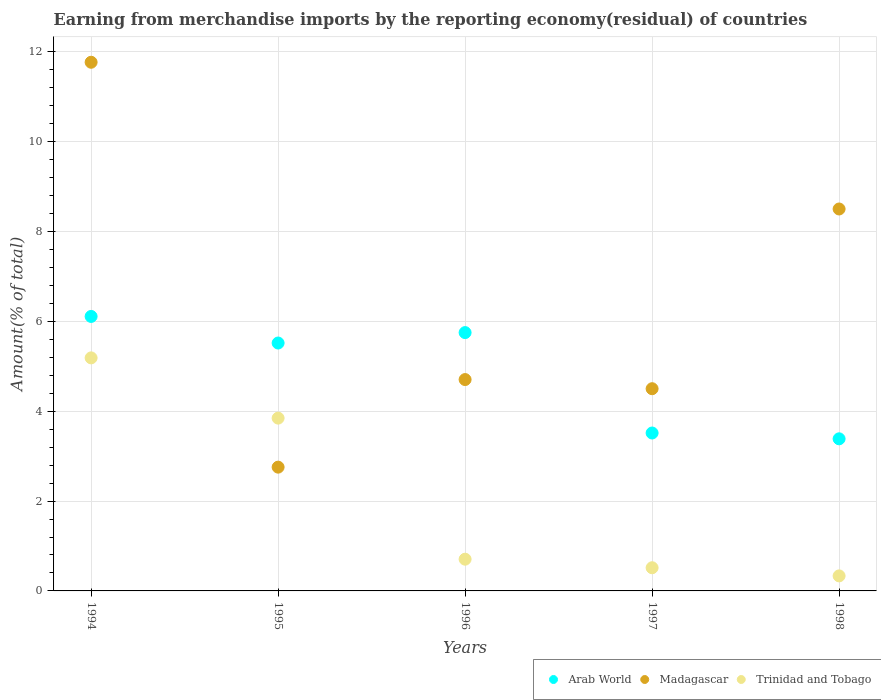How many different coloured dotlines are there?
Ensure brevity in your answer.  3. Is the number of dotlines equal to the number of legend labels?
Keep it short and to the point. Yes. What is the percentage of amount earned from merchandise imports in Trinidad and Tobago in 1996?
Your answer should be compact. 0.71. Across all years, what is the maximum percentage of amount earned from merchandise imports in Arab World?
Provide a succinct answer. 6.11. Across all years, what is the minimum percentage of amount earned from merchandise imports in Trinidad and Tobago?
Provide a succinct answer. 0.33. In which year was the percentage of amount earned from merchandise imports in Madagascar maximum?
Make the answer very short. 1994. In which year was the percentage of amount earned from merchandise imports in Arab World minimum?
Make the answer very short. 1998. What is the total percentage of amount earned from merchandise imports in Arab World in the graph?
Provide a succinct answer. 24.28. What is the difference between the percentage of amount earned from merchandise imports in Madagascar in 1995 and that in 1998?
Offer a terse response. -5.75. What is the difference between the percentage of amount earned from merchandise imports in Madagascar in 1998 and the percentage of amount earned from merchandise imports in Trinidad and Tobago in 1995?
Make the answer very short. 4.66. What is the average percentage of amount earned from merchandise imports in Arab World per year?
Provide a succinct answer. 4.86. In the year 1994, what is the difference between the percentage of amount earned from merchandise imports in Madagascar and percentage of amount earned from merchandise imports in Arab World?
Make the answer very short. 5.66. What is the ratio of the percentage of amount earned from merchandise imports in Arab World in 1996 to that in 1998?
Your answer should be compact. 1.7. Is the difference between the percentage of amount earned from merchandise imports in Madagascar in 1994 and 1998 greater than the difference between the percentage of amount earned from merchandise imports in Arab World in 1994 and 1998?
Provide a short and direct response. Yes. What is the difference between the highest and the second highest percentage of amount earned from merchandise imports in Arab World?
Give a very brief answer. 0.36. What is the difference between the highest and the lowest percentage of amount earned from merchandise imports in Trinidad and Tobago?
Ensure brevity in your answer.  4.85. In how many years, is the percentage of amount earned from merchandise imports in Trinidad and Tobago greater than the average percentage of amount earned from merchandise imports in Trinidad and Tobago taken over all years?
Offer a very short reply. 2. Is it the case that in every year, the sum of the percentage of amount earned from merchandise imports in Trinidad and Tobago and percentage of amount earned from merchandise imports in Arab World  is greater than the percentage of amount earned from merchandise imports in Madagascar?
Offer a terse response. No. Does the percentage of amount earned from merchandise imports in Arab World monotonically increase over the years?
Offer a very short reply. No. Is the percentage of amount earned from merchandise imports in Madagascar strictly less than the percentage of amount earned from merchandise imports in Trinidad and Tobago over the years?
Make the answer very short. No. How many years are there in the graph?
Your answer should be very brief. 5. What is the difference between two consecutive major ticks on the Y-axis?
Keep it short and to the point. 2. How many legend labels are there?
Offer a terse response. 3. How are the legend labels stacked?
Your answer should be compact. Horizontal. What is the title of the graph?
Offer a very short reply. Earning from merchandise imports by the reporting economy(residual) of countries. Does "Latin America(all income levels)" appear as one of the legend labels in the graph?
Offer a terse response. No. What is the label or title of the X-axis?
Your response must be concise. Years. What is the label or title of the Y-axis?
Provide a short and direct response. Amount(% of total). What is the Amount(% of total) of Arab World in 1994?
Make the answer very short. 6.11. What is the Amount(% of total) of Madagascar in 1994?
Offer a terse response. 11.77. What is the Amount(% of total) in Trinidad and Tobago in 1994?
Your answer should be very brief. 5.19. What is the Amount(% of total) in Arab World in 1995?
Your answer should be compact. 5.52. What is the Amount(% of total) of Madagascar in 1995?
Offer a very short reply. 2.76. What is the Amount(% of total) in Trinidad and Tobago in 1995?
Your answer should be very brief. 3.85. What is the Amount(% of total) in Arab World in 1996?
Provide a succinct answer. 5.75. What is the Amount(% of total) in Madagascar in 1996?
Make the answer very short. 4.71. What is the Amount(% of total) of Trinidad and Tobago in 1996?
Offer a terse response. 0.71. What is the Amount(% of total) of Arab World in 1997?
Give a very brief answer. 3.52. What is the Amount(% of total) of Madagascar in 1997?
Your answer should be very brief. 4.5. What is the Amount(% of total) in Trinidad and Tobago in 1997?
Make the answer very short. 0.52. What is the Amount(% of total) in Arab World in 1998?
Provide a short and direct response. 3.39. What is the Amount(% of total) in Madagascar in 1998?
Ensure brevity in your answer.  8.5. What is the Amount(% of total) in Trinidad and Tobago in 1998?
Provide a short and direct response. 0.33. Across all years, what is the maximum Amount(% of total) of Arab World?
Provide a short and direct response. 6.11. Across all years, what is the maximum Amount(% of total) in Madagascar?
Offer a terse response. 11.77. Across all years, what is the maximum Amount(% of total) of Trinidad and Tobago?
Provide a short and direct response. 5.19. Across all years, what is the minimum Amount(% of total) in Arab World?
Your answer should be compact. 3.39. Across all years, what is the minimum Amount(% of total) in Madagascar?
Offer a terse response. 2.76. Across all years, what is the minimum Amount(% of total) in Trinidad and Tobago?
Keep it short and to the point. 0.33. What is the total Amount(% of total) of Arab World in the graph?
Provide a short and direct response. 24.28. What is the total Amount(% of total) in Madagascar in the graph?
Keep it short and to the point. 32.23. What is the total Amount(% of total) of Trinidad and Tobago in the graph?
Offer a terse response. 10.59. What is the difference between the Amount(% of total) in Arab World in 1994 and that in 1995?
Give a very brief answer. 0.59. What is the difference between the Amount(% of total) in Madagascar in 1994 and that in 1995?
Your answer should be compact. 9.01. What is the difference between the Amount(% of total) in Trinidad and Tobago in 1994 and that in 1995?
Keep it short and to the point. 1.34. What is the difference between the Amount(% of total) of Arab World in 1994 and that in 1996?
Your answer should be very brief. 0.36. What is the difference between the Amount(% of total) of Madagascar in 1994 and that in 1996?
Offer a terse response. 7.06. What is the difference between the Amount(% of total) in Trinidad and Tobago in 1994 and that in 1996?
Your answer should be very brief. 4.48. What is the difference between the Amount(% of total) of Arab World in 1994 and that in 1997?
Your answer should be very brief. 2.6. What is the difference between the Amount(% of total) in Madagascar in 1994 and that in 1997?
Ensure brevity in your answer.  7.27. What is the difference between the Amount(% of total) in Trinidad and Tobago in 1994 and that in 1997?
Your answer should be compact. 4.67. What is the difference between the Amount(% of total) of Arab World in 1994 and that in 1998?
Provide a succinct answer. 2.72. What is the difference between the Amount(% of total) in Madagascar in 1994 and that in 1998?
Keep it short and to the point. 3.27. What is the difference between the Amount(% of total) of Trinidad and Tobago in 1994 and that in 1998?
Your answer should be very brief. 4.85. What is the difference between the Amount(% of total) in Arab World in 1995 and that in 1996?
Your answer should be very brief. -0.23. What is the difference between the Amount(% of total) of Madagascar in 1995 and that in 1996?
Ensure brevity in your answer.  -1.95. What is the difference between the Amount(% of total) in Trinidad and Tobago in 1995 and that in 1996?
Give a very brief answer. 3.14. What is the difference between the Amount(% of total) of Arab World in 1995 and that in 1997?
Give a very brief answer. 2. What is the difference between the Amount(% of total) of Madagascar in 1995 and that in 1997?
Provide a short and direct response. -1.75. What is the difference between the Amount(% of total) in Trinidad and Tobago in 1995 and that in 1997?
Provide a short and direct response. 3.33. What is the difference between the Amount(% of total) of Arab World in 1995 and that in 1998?
Your answer should be compact. 2.13. What is the difference between the Amount(% of total) in Madagascar in 1995 and that in 1998?
Your answer should be compact. -5.75. What is the difference between the Amount(% of total) in Trinidad and Tobago in 1995 and that in 1998?
Give a very brief answer. 3.51. What is the difference between the Amount(% of total) of Arab World in 1996 and that in 1997?
Offer a terse response. 2.24. What is the difference between the Amount(% of total) in Madagascar in 1996 and that in 1997?
Your answer should be compact. 0.2. What is the difference between the Amount(% of total) in Trinidad and Tobago in 1996 and that in 1997?
Offer a very short reply. 0.19. What is the difference between the Amount(% of total) of Arab World in 1996 and that in 1998?
Give a very brief answer. 2.36. What is the difference between the Amount(% of total) of Madagascar in 1996 and that in 1998?
Keep it short and to the point. -3.8. What is the difference between the Amount(% of total) in Trinidad and Tobago in 1996 and that in 1998?
Give a very brief answer. 0.37. What is the difference between the Amount(% of total) in Arab World in 1997 and that in 1998?
Provide a short and direct response. 0.13. What is the difference between the Amount(% of total) of Madagascar in 1997 and that in 1998?
Give a very brief answer. -4. What is the difference between the Amount(% of total) in Trinidad and Tobago in 1997 and that in 1998?
Your answer should be compact. 0.18. What is the difference between the Amount(% of total) of Arab World in 1994 and the Amount(% of total) of Madagascar in 1995?
Give a very brief answer. 3.35. What is the difference between the Amount(% of total) of Arab World in 1994 and the Amount(% of total) of Trinidad and Tobago in 1995?
Your response must be concise. 2.26. What is the difference between the Amount(% of total) in Madagascar in 1994 and the Amount(% of total) in Trinidad and Tobago in 1995?
Give a very brief answer. 7.92. What is the difference between the Amount(% of total) in Arab World in 1994 and the Amount(% of total) in Madagascar in 1996?
Provide a short and direct response. 1.41. What is the difference between the Amount(% of total) of Arab World in 1994 and the Amount(% of total) of Trinidad and Tobago in 1996?
Your answer should be compact. 5.4. What is the difference between the Amount(% of total) in Madagascar in 1994 and the Amount(% of total) in Trinidad and Tobago in 1996?
Keep it short and to the point. 11.06. What is the difference between the Amount(% of total) in Arab World in 1994 and the Amount(% of total) in Madagascar in 1997?
Ensure brevity in your answer.  1.61. What is the difference between the Amount(% of total) in Arab World in 1994 and the Amount(% of total) in Trinidad and Tobago in 1997?
Provide a succinct answer. 5.59. What is the difference between the Amount(% of total) in Madagascar in 1994 and the Amount(% of total) in Trinidad and Tobago in 1997?
Provide a succinct answer. 11.25. What is the difference between the Amount(% of total) in Arab World in 1994 and the Amount(% of total) in Madagascar in 1998?
Provide a short and direct response. -2.39. What is the difference between the Amount(% of total) in Arab World in 1994 and the Amount(% of total) in Trinidad and Tobago in 1998?
Your answer should be very brief. 5.78. What is the difference between the Amount(% of total) of Madagascar in 1994 and the Amount(% of total) of Trinidad and Tobago in 1998?
Make the answer very short. 11.43. What is the difference between the Amount(% of total) of Arab World in 1995 and the Amount(% of total) of Madagascar in 1996?
Offer a very short reply. 0.81. What is the difference between the Amount(% of total) in Arab World in 1995 and the Amount(% of total) in Trinidad and Tobago in 1996?
Provide a short and direct response. 4.81. What is the difference between the Amount(% of total) of Madagascar in 1995 and the Amount(% of total) of Trinidad and Tobago in 1996?
Give a very brief answer. 2.05. What is the difference between the Amount(% of total) in Arab World in 1995 and the Amount(% of total) in Madagascar in 1997?
Offer a terse response. 1.02. What is the difference between the Amount(% of total) of Arab World in 1995 and the Amount(% of total) of Trinidad and Tobago in 1997?
Make the answer very short. 5. What is the difference between the Amount(% of total) in Madagascar in 1995 and the Amount(% of total) in Trinidad and Tobago in 1997?
Provide a short and direct response. 2.24. What is the difference between the Amount(% of total) of Arab World in 1995 and the Amount(% of total) of Madagascar in 1998?
Your response must be concise. -2.98. What is the difference between the Amount(% of total) of Arab World in 1995 and the Amount(% of total) of Trinidad and Tobago in 1998?
Your answer should be very brief. 5.18. What is the difference between the Amount(% of total) of Madagascar in 1995 and the Amount(% of total) of Trinidad and Tobago in 1998?
Keep it short and to the point. 2.42. What is the difference between the Amount(% of total) of Arab World in 1996 and the Amount(% of total) of Madagascar in 1997?
Keep it short and to the point. 1.25. What is the difference between the Amount(% of total) of Arab World in 1996 and the Amount(% of total) of Trinidad and Tobago in 1997?
Keep it short and to the point. 5.23. What is the difference between the Amount(% of total) in Madagascar in 1996 and the Amount(% of total) in Trinidad and Tobago in 1997?
Ensure brevity in your answer.  4.19. What is the difference between the Amount(% of total) in Arab World in 1996 and the Amount(% of total) in Madagascar in 1998?
Give a very brief answer. -2.75. What is the difference between the Amount(% of total) in Arab World in 1996 and the Amount(% of total) in Trinidad and Tobago in 1998?
Your answer should be very brief. 5.42. What is the difference between the Amount(% of total) in Madagascar in 1996 and the Amount(% of total) in Trinidad and Tobago in 1998?
Provide a succinct answer. 4.37. What is the difference between the Amount(% of total) of Arab World in 1997 and the Amount(% of total) of Madagascar in 1998?
Your response must be concise. -4.99. What is the difference between the Amount(% of total) of Arab World in 1997 and the Amount(% of total) of Trinidad and Tobago in 1998?
Offer a terse response. 3.18. What is the difference between the Amount(% of total) of Madagascar in 1997 and the Amount(% of total) of Trinidad and Tobago in 1998?
Provide a succinct answer. 4.17. What is the average Amount(% of total) in Arab World per year?
Your answer should be compact. 4.86. What is the average Amount(% of total) of Madagascar per year?
Your response must be concise. 6.45. What is the average Amount(% of total) in Trinidad and Tobago per year?
Offer a very short reply. 2.12. In the year 1994, what is the difference between the Amount(% of total) of Arab World and Amount(% of total) of Madagascar?
Provide a short and direct response. -5.66. In the year 1994, what is the difference between the Amount(% of total) in Arab World and Amount(% of total) in Trinidad and Tobago?
Provide a short and direct response. 0.92. In the year 1994, what is the difference between the Amount(% of total) of Madagascar and Amount(% of total) of Trinidad and Tobago?
Make the answer very short. 6.58. In the year 1995, what is the difference between the Amount(% of total) of Arab World and Amount(% of total) of Madagascar?
Your answer should be compact. 2.76. In the year 1995, what is the difference between the Amount(% of total) of Arab World and Amount(% of total) of Trinidad and Tobago?
Ensure brevity in your answer.  1.67. In the year 1995, what is the difference between the Amount(% of total) in Madagascar and Amount(% of total) in Trinidad and Tobago?
Offer a very short reply. -1.09. In the year 1996, what is the difference between the Amount(% of total) of Arab World and Amount(% of total) of Madagascar?
Offer a terse response. 1.05. In the year 1996, what is the difference between the Amount(% of total) of Arab World and Amount(% of total) of Trinidad and Tobago?
Your answer should be compact. 5.04. In the year 1996, what is the difference between the Amount(% of total) of Madagascar and Amount(% of total) of Trinidad and Tobago?
Ensure brevity in your answer.  4. In the year 1997, what is the difference between the Amount(% of total) in Arab World and Amount(% of total) in Madagascar?
Give a very brief answer. -0.99. In the year 1997, what is the difference between the Amount(% of total) in Arab World and Amount(% of total) in Trinidad and Tobago?
Provide a short and direct response. 3. In the year 1997, what is the difference between the Amount(% of total) of Madagascar and Amount(% of total) of Trinidad and Tobago?
Provide a short and direct response. 3.99. In the year 1998, what is the difference between the Amount(% of total) of Arab World and Amount(% of total) of Madagascar?
Provide a succinct answer. -5.12. In the year 1998, what is the difference between the Amount(% of total) in Arab World and Amount(% of total) in Trinidad and Tobago?
Ensure brevity in your answer.  3.05. In the year 1998, what is the difference between the Amount(% of total) of Madagascar and Amount(% of total) of Trinidad and Tobago?
Your answer should be compact. 8.17. What is the ratio of the Amount(% of total) in Arab World in 1994 to that in 1995?
Provide a short and direct response. 1.11. What is the ratio of the Amount(% of total) of Madagascar in 1994 to that in 1995?
Your answer should be compact. 4.27. What is the ratio of the Amount(% of total) in Trinidad and Tobago in 1994 to that in 1995?
Your answer should be very brief. 1.35. What is the ratio of the Amount(% of total) of Madagascar in 1994 to that in 1996?
Offer a very short reply. 2.5. What is the ratio of the Amount(% of total) of Trinidad and Tobago in 1994 to that in 1996?
Keep it short and to the point. 7.34. What is the ratio of the Amount(% of total) of Arab World in 1994 to that in 1997?
Keep it short and to the point. 1.74. What is the ratio of the Amount(% of total) of Madagascar in 1994 to that in 1997?
Offer a very short reply. 2.61. What is the ratio of the Amount(% of total) of Trinidad and Tobago in 1994 to that in 1997?
Your response must be concise. 10.06. What is the ratio of the Amount(% of total) in Arab World in 1994 to that in 1998?
Offer a very short reply. 1.8. What is the ratio of the Amount(% of total) in Madagascar in 1994 to that in 1998?
Make the answer very short. 1.38. What is the ratio of the Amount(% of total) of Trinidad and Tobago in 1994 to that in 1998?
Offer a terse response. 15.5. What is the ratio of the Amount(% of total) in Arab World in 1995 to that in 1996?
Your response must be concise. 0.96. What is the ratio of the Amount(% of total) in Madagascar in 1995 to that in 1996?
Your answer should be very brief. 0.59. What is the ratio of the Amount(% of total) in Trinidad and Tobago in 1995 to that in 1996?
Your answer should be very brief. 5.45. What is the ratio of the Amount(% of total) in Arab World in 1995 to that in 1997?
Your answer should be compact. 1.57. What is the ratio of the Amount(% of total) of Madagascar in 1995 to that in 1997?
Keep it short and to the point. 0.61. What is the ratio of the Amount(% of total) in Trinidad and Tobago in 1995 to that in 1997?
Make the answer very short. 7.46. What is the ratio of the Amount(% of total) in Arab World in 1995 to that in 1998?
Offer a very short reply. 1.63. What is the ratio of the Amount(% of total) in Madagascar in 1995 to that in 1998?
Your response must be concise. 0.32. What is the ratio of the Amount(% of total) of Trinidad and Tobago in 1995 to that in 1998?
Ensure brevity in your answer.  11.49. What is the ratio of the Amount(% of total) in Arab World in 1996 to that in 1997?
Your answer should be very brief. 1.64. What is the ratio of the Amount(% of total) in Madagascar in 1996 to that in 1997?
Keep it short and to the point. 1.05. What is the ratio of the Amount(% of total) of Trinidad and Tobago in 1996 to that in 1997?
Make the answer very short. 1.37. What is the ratio of the Amount(% of total) in Arab World in 1996 to that in 1998?
Make the answer very short. 1.7. What is the ratio of the Amount(% of total) of Madagascar in 1996 to that in 1998?
Your answer should be compact. 0.55. What is the ratio of the Amount(% of total) in Trinidad and Tobago in 1996 to that in 1998?
Give a very brief answer. 2.11. What is the ratio of the Amount(% of total) of Arab World in 1997 to that in 1998?
Make the answer very short. 1.04. What is the ratio of the Amount(% of total) of Madagascar in 1997 to that in 1998?
Your answer should be compact. 0.53. What is the ratio of the Amount(% of total) in Trinidad and Tobago in 1997 to that in 1998?
Ensure brevity in your answer.  1.54. What is the difference between the highest and the second highest Amount(% of total) of Arab World?
Make the answer very short. 0.36. What is the difference between the highest and the second highest Amount(% of total) in Madagascar?
Ensure brevity in your answer.  3.27. What is the difference between the highest and the second highest Amount(% of total) in Trinidad and Tobago?
Offer a very short reply. 1.34. What is the difference between the highest and the lowest Amount(% of total) of Arab World?
Your answer should be compact. 2.72. What is the difference between the highest and the lowest Amount(% of total) in Madagascar?
Ensure brevity in your answer.  9.01. What is the difference between the highest and the lowest Amount(% of total) in Trinidad and Tobago?
Offer a terse response. 4.85. 